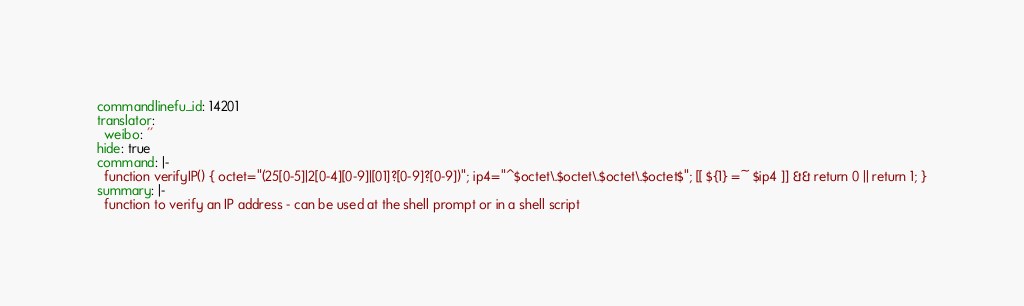Convert code to text. <code><loc_0><loc_0><loc_500><loc_500><_YAML_>commandlinefu_id: 14201
translator:
  weibo: ''
hide: true
command: |-
  function verifyIP() { octet="(25[0-5]|2[0-4][0-9]|[01]?[0-9]?[0-9])"; ip4="^$octet\.$octet\.$octet\.$octet$"; [[ ${1} =~ $ip4 ]] && return 0 || return 1; }
summary: |-
  function to verify an IP address - can be used at the shell prompt or in a shell script
</code> 